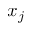Convert formula to latex. <formula><loc_0><loc_0><loc_500><loc_500>x _ { j }</formula> 